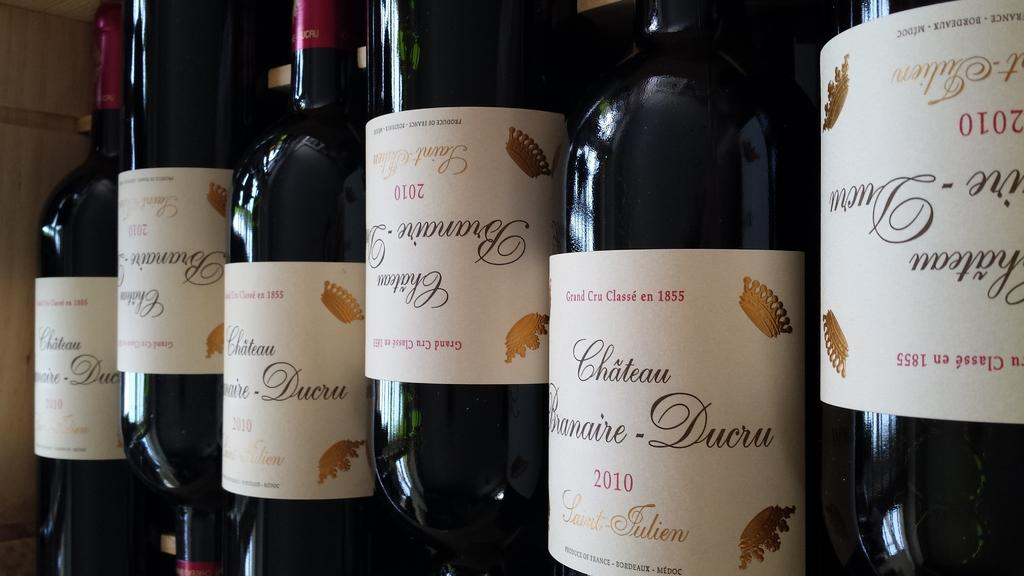<image>
Summarize the visual content of the image. Wine bottles with red letters stating, "Grand Cru Classe en 1855" at the top of the labels. 